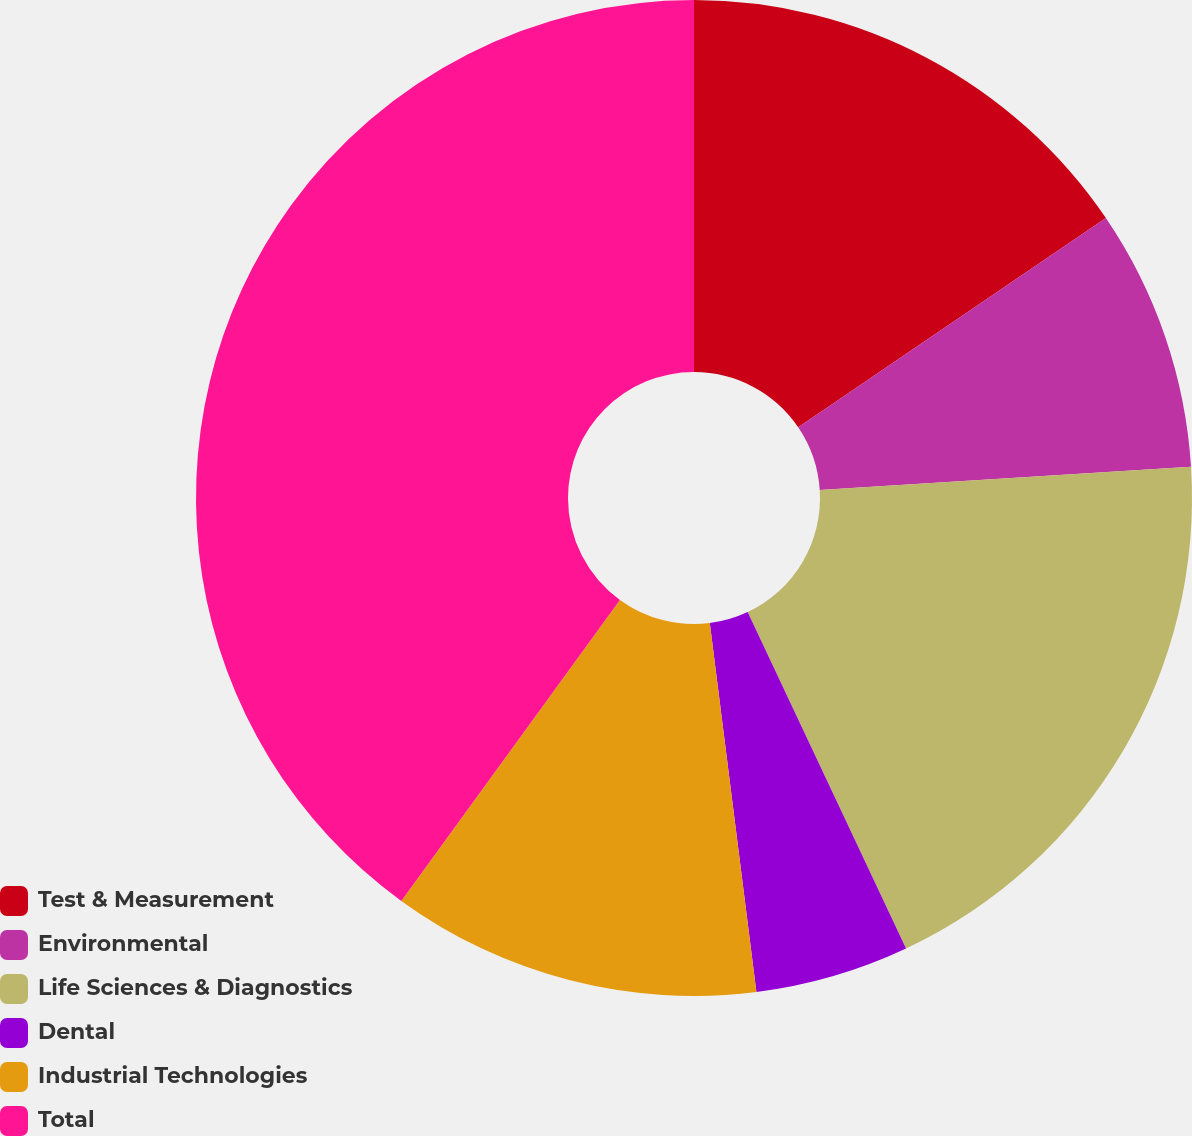Convert chart to OTSL. <chart><loc_0><loc_0><loc_500><loc_500><pie_chart><fcel>Test & Measurement<fcel>Environmental<fcel>Life Sciences & Diagnostics<fcel>Dental<fcel>Industrial Technologies<fcel>Total<nl><fcel>15.5%<fcel>8.5%<fcel>19.0%<fcel>5.0%<fcel>12.0%<fcel>40.0%<nl></chart> 